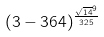Convert formula to latex. <formula><loc_0><loc_0><loc_500><loc_500>( 3 - 3 6 4 ) ^ { \frac { \sqrt { 1 4 } ^ { 9 } } { 3 2 5 } }</formula> 